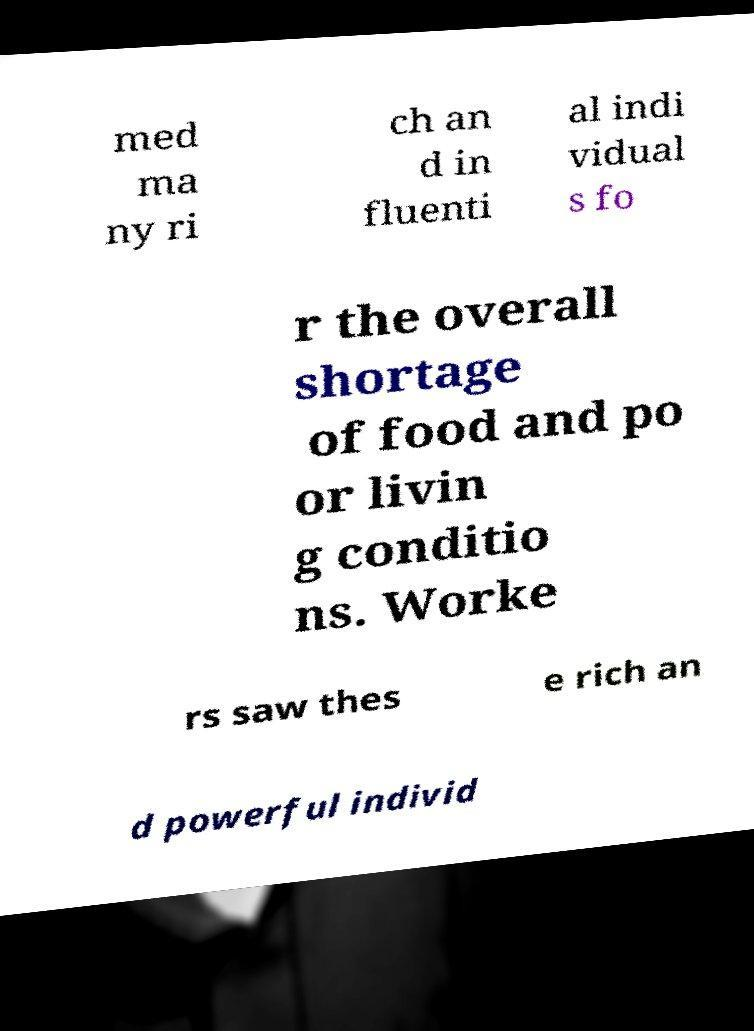Please read and relay the text visible in this image. What does it say? med ma ny ri ch an d in fluenti al indi vidual s fo r the overall shortage of food and po or livin g conditio ns. Worke rs saw thes e rich an d powerful individ 